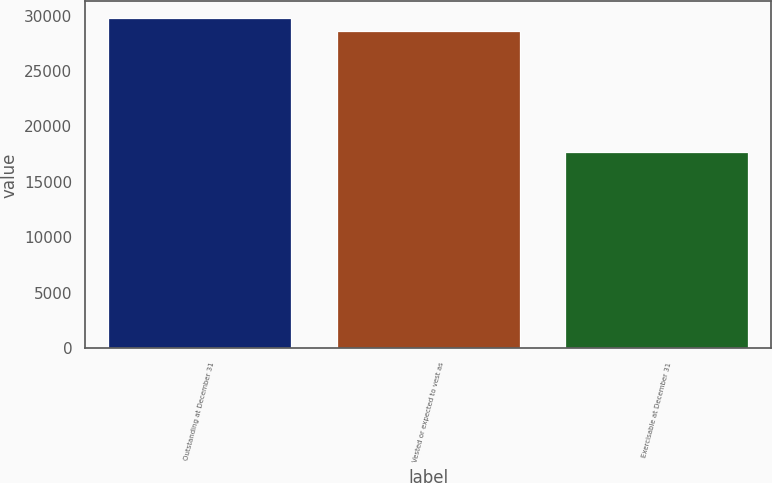Convert chart to OTSL. <chart><loc_0><loc_0><loc_500><loc_500><bar_chart><fcel>Outstanding at December 31<fcel>Vested or expected to vest as<fcel>Exercisable at December 31<nl><fcel>29781.7<fcel>28642<fcel>17732<nl></chart> 